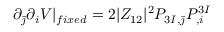<formula> <loc_0><loc_0><loc_500><loc_500>\partial _ { \bar { \jmath } } \partial _ { i } V | _ { f i x e d } = 2 | Z _ { 1 2 } | ^ { 2 } P _ { 3 I , \bar { \jmath } } P _ { , i } ^ { 3 I }</formula> 